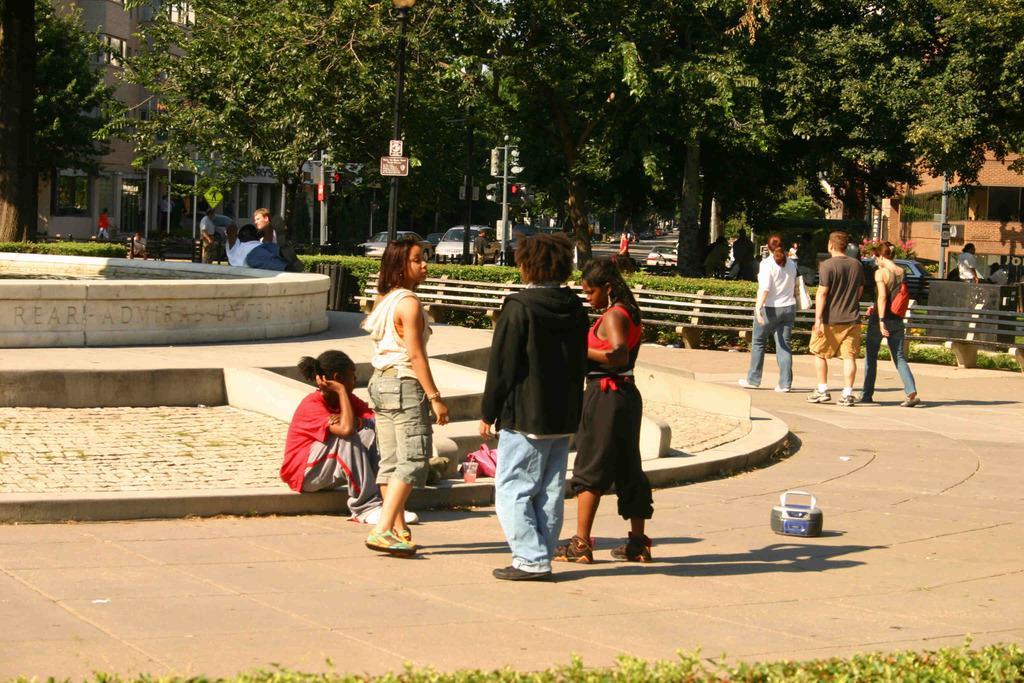How would you summarize this image in a sentence or two? In this picture there are group of people walking and there are group of people standing and there are group of people sitting. At the back there are buildings and trees and poles and there is a wooden railing and there is an object on the pavement. On the left side of the image it looks like fountain There are vehicles on the road. At the bottom there are plants. 